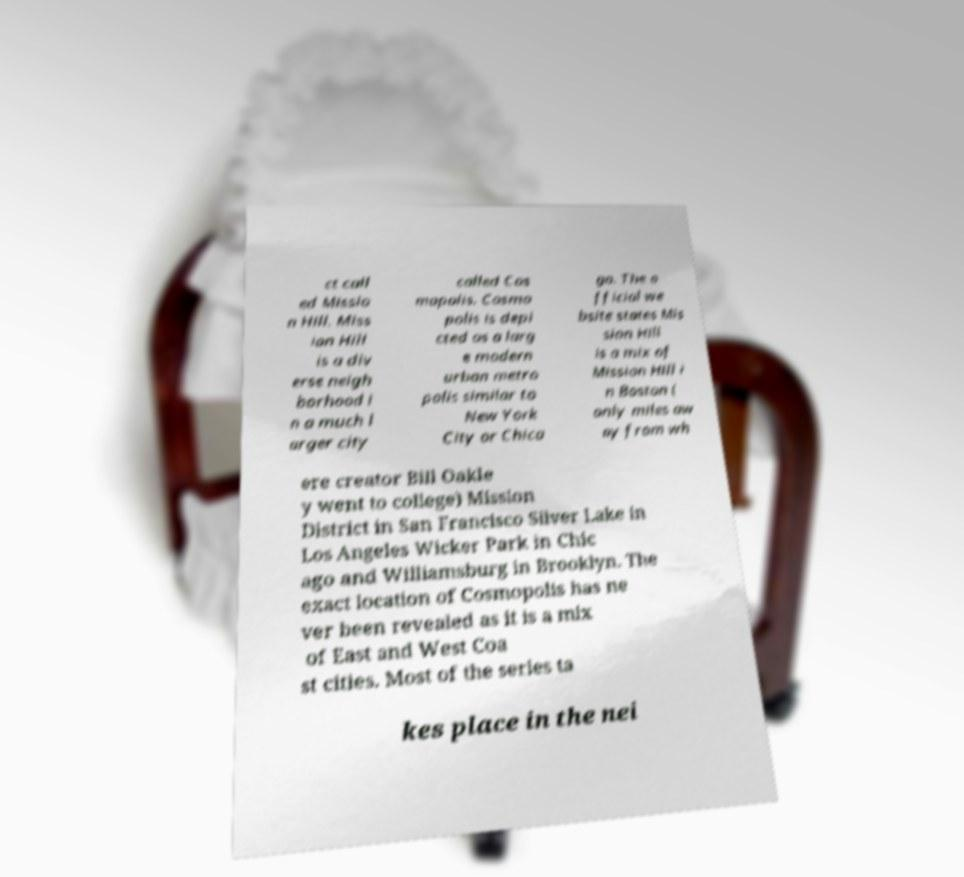Could you assist in decoding the text presented in this image and type it out clearly? ct call ed Missio n Hill. Miss ion Hill is a div erse neigh borhood i n a much l arger city called Cos mopolis. Cosmo polis is depi cted as a larg e modern urban metro polis similar to New York City or Chica go. The o fficial we bsite states Mis sion Hill is a mix of Mission Hill i n Boston ( only miles aw ay from wh ere creator Bill Oakle y went to college) Mission District in San Francisco Silver Lake in Los Angeles Wicker Park in Chic ago and Williamsburg in Brooklyn. The exact location of Cosmopolis has ne ver been revealed as it is a mix of East and West Coa st cities. Most of the series ta kes place in the nei 